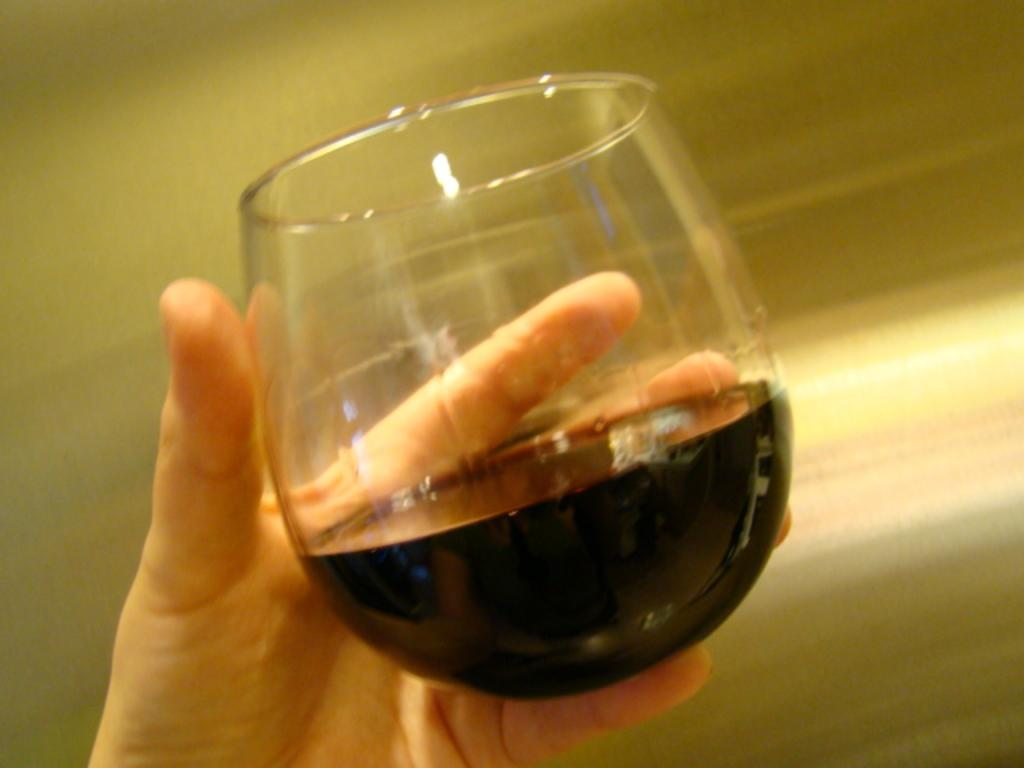What is being held by the hand in the image? The hand is holding a wine glass. What is inside the wine glass? The wine glass contains a black-colored liquid. Can you describe the background of the image? The background of the image is blurry. What type of wool is being spun by the frog in the image? There is no frog or wool present in the image. 